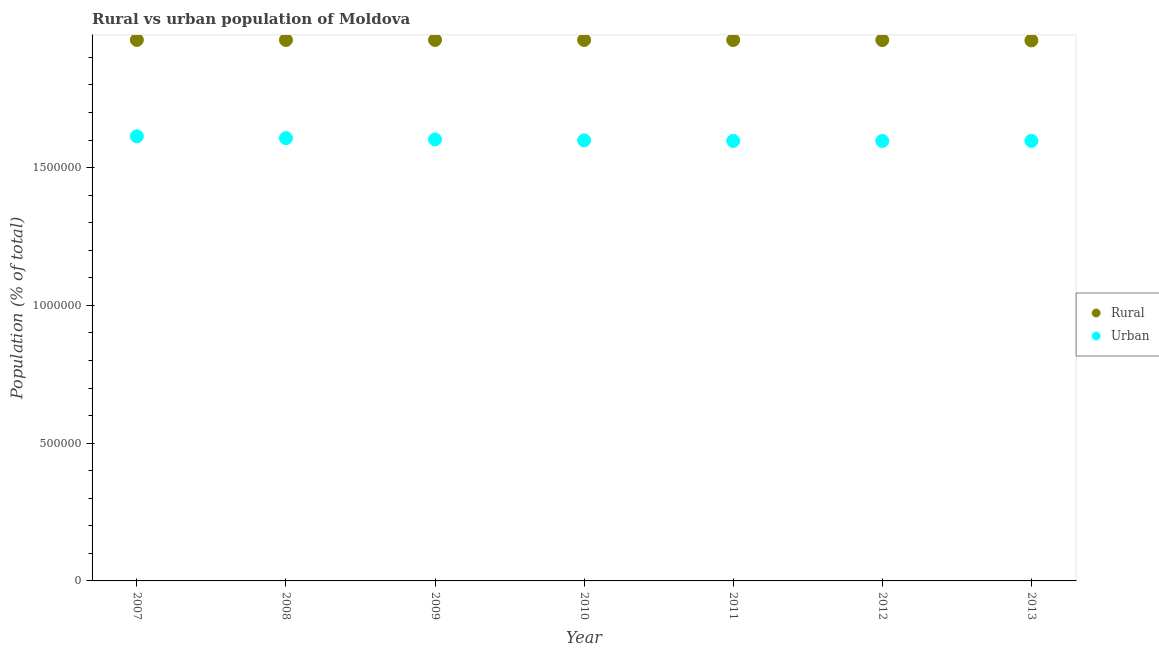What is the urban population density in 2012?
Ensure brevity in your answer.  1.60e+06. Across all years, what is the maximum urban population density?
Your answer should be very brief. 1.61e+06. Across all years, what is the minimum urban population density?
Provide a short and direct response. 1.60e+06. In which year was the rural population density maximum?
Give a very brief answer. 2007. What is the total rural population density in the graph?
Provide a succinct answer. 1.37e+07. What is the difference between the rural population density in 2010 and that in 2013?
Your answer should be compact. 1668. What is the difference between the rural population density in 2007 and the urban population density in 2009?
Offer a very short reply. 3.61e+05. What is the average rural population density per year?
Offer a terse response. 1.96e+06. In the year 2011, what is the difference between the rural population density and urban population density?
Give a very brief answer. 3.66e+05. What is the ratio of the rural population density in 2012 to that in 2013?
Your answer should be compact. 1. Is the difference between the urban population density in 2007 and 2011 greater than the difference between the rural population density in 2007 and 2011?
Offer a terse response. Yes. What is the difference between the highest and the lowest rural population density?
Give a very brief answer. 1849. Is the rural population density strictly greater than the urban population density over the years?
Ensure brevity in your answer.  Yes. How many dotlines are there?
Offer a terse response. 2. How many years are there in the graph?
Provide a short and direct response. 7. What is the difference between two consecutive major ticks on the Y-axis?
Provide a short and direct response. 5.00e+05. Are the values on the major ticks of Y-axis written in scientific E-notation?
Your answer should be compact. No. Where does the legend appear in the graph?
Offer a very short reply. Center right. How many legend labels are there?
Offer a terse response. 2. What is the title of the graph?
Keep it short and to the point. Rural vs urban population of Moldova. What is the label or title of the Y-axis?
Give a very brief answer. Population (% of total). What is the Population (% of total) in Rural in 2007?
Your answer should be very brief. 1.96e+06. What is the Population (% of total) in Urban in 2007?
Ensure brevity in your answer.  1.61e+06. What is the Population (% of total) of Rural in 2008?
Provide a short and direct response. 1.96e+06. What is the Population (% of total) in Urban in 2008?
Keep it short and to the point. 1.61e+06. What is the Population (% of total) in Rural in 2009?
Provide a short and direct response. 1.96e+06. What is the Population (% of total) of Urban in 2009?
Provide a short and direct response. 1.60e+06. What is the Population (% of total) in Rural in 2010?
Your response must be concise. 1.96e+06. What is the Population (% of total) of Urban in 2010?
Offer a very short reply. 1.60e+06. What is the Population (% of total) in Rural in 2011?
Keep it short and to the point. 1.96e+06. What is the Population (% of total) in Urban in 2011?
Make the answer very short. 1.60e+06. What is the Population (% of total) in Rural in 2012?
Provide a succinct answer. 1.96e+06. What is the Population (% of total) in Urban in 2012?
Make the answer very short. 1.60e+06. What is the Population (% of total) of Rural in 2013?
Your response must be concise. 1.96e+06. What is the Population (% of total) of Urban in 2013?
Your answer should be compact. 1.60e+06. Across all years, what is the maximum Population (% of total) in Rural?
Provide a succinct answer. 1.96e+06. Across all years, what is the maximum Population (% of total) of Urban?
Give a very brief answer. 1.61e+06. Across all years, what is the minimum Population (% of total) in Rural?
Offer a terse response. 1.96e+06. Across all years, what is the minimum Population (% of total) in Urban?
Provide a short and direct response. 1.60e+06. What is the total Population (% of total) in Rural in the graph?
Make the answer very short. 1.37e+07. What is the total Population (% of total) in Urban in the graph?
Your response must be concise. 1.12e+07. What is the difference between the Population (% of total) in Rural in 2007 and that in 2008?
Your answer should be very brief. 199. What is the difference between the Population (% of total) of Urban in 2007 and that in 2008?
Ensure brevity in your answer.  6603. What is the difference between the Population (% of total) in Urban in 2007 and that in 2009?
Provide a short and direct response. 1.13e+04. What is the difference between the Population (% of total) in Rural in 2007 and that in 2010?
Make the answer very short. 181. What is the difference between the Population (% of total) of Urban in 2007 and that in 2010?
Give a very brief answer. 1.47e+04. What is the difference between the Population (% of total) of Rural in 2007 and that in 2011?
Ensure brevity in your answer.  354. What is the difference between the Population (% of total) of Urban in 2007 and that in 2011?
Ensure brevity in your answer.  1.66e+04. What is the difference between the Population (% of total) in Rural in 2007 and that in 2012?
Offer a very short reply. 540. What is the difference between the Population (% of total) in Urban in 2007 and that in 2012?
Your answer should be compact. 1.69e+04. What is the difference between the Population (% of total) in Rural in 2007 and that in 2013?
Provide a short and direct response. 1849. What is the difference between the Population (% of total) of Urban in 2007 and that in 2013?
Ensure brevity in your answer.  1.65e+04. What is the difference between the Population (% of total) of Rural in 2008 and that in 2009?
Ensure brevity in your answer.  -197. What is the difference between the Population (% of total) of Urban in 2008 and that in 2009?
Provide a succinct answer. 4701. What is the difference between the Population (% of total) in Rural in 2008 and that in 2010?
Provide a short and direct response. -18. What is the difference between the Population (% of total) in Urban in 2008 and that in 2010?
Your response must be concise. 8081. What is the difference between the Population (% of total) in Rural in 2008 and that in 2011?
Make the answer very short. 155. What is the difference between the Population (% of total) in Urban in 2008 and that in 2011?
Give a very brief answer. 9967. What is the difference between the Population (% of total) in Rural in 2008 and that in 2012?
Ensure brevity in your answer.  341. What is the difference between the Population (% of total) of Urban in 2008 and that in 2012?
Ensure brevity in your answer.  1.02e+04. What is the difference between the Population (% of total) in Rural in 2008 and that in 2013?
Provide a succinct answer. 1650. What is the difference between the Population (% of total) in Urban in 2008 and that in 2013?
Provide a short and direct response. 9892. What is the difference between the Population (% of total) in Rural in 2009 and that in 2010?
Your answer should be compact. 179. What is the difference between the Population (% of total) in Urban in 2009 and that in 2010?
Make the answer very short. 3380. What is the difference between the Population (% of total) in Rural in 2009 and that in 2011?
Offer a very short reply. 352. What is the difference between the Population (% of total) of Urban in 2009 and that in 2011?
Make the answer very short. 5266. What is the difference between the Population (% of total) of Rural in 2009 and that in 2012?
Provide a short and direct response. 538. What is the difference between the Population (% of total) of Urban in 2009 and that in 2012?
Provide a short and direct response. 5547. What is the difference between the Population (% of total) in Rural in 2009 and that in 2013?
Make the answer very short. 1847. What is the difference between the Population (% of total) in Urban in 2009 and that in 2013?
Ensure brevity in your answer.  5191. What is the difference between the Population (% of total) in Rural in 2010 and that in 2011?
Offer a terse response. 173. What is the difference between the Population (% of total) in Urban in 2010 and that in 2011?
Your answer should be very brief. 1886. What is the difference between the Population (% of total) in Rural in 2010 and that in 2012?
Your answer should be compact. 359. What is the difference between the Population (% of total) in Urban in 2010 and that in 2012?
Offer a very short reply. 2167. What is the difference between the Population (% of total) in Rural in 2010 and that in 2013?
Give a very brief answer. 1668. What is the difference between the Population (% of total) in Urban in 2010 and that in 2013?
Provide a short and direct response. 1811. What is the difference between the Population (% of total) in Rural in 2011 and that in 2012?
Keep it short and to the point. 186. What is the difference between the Population (% of total) in Urban in 2011 and that in 2012?
Your response must be concise. 281. What is the difference between the Population (% of total) of Rural in 2011 and that in 2013?
Your answer should be compact. 1495. What is the difference between the Population (% of total) in Urban in 2011 and that in 2013?
Offer a terse response. -75. What is the difference between the Population (% of total) of Rural in 2012 and that in 2013?
Your answer should be very brief. 1309. What is the difference between the Population (% of total) in Urban in 2012 and that in 2013?
Your response must be concise. -356. What is the difference between the Population (% of total) of Rural in 2007 and the Population (% of total) of Urban in 2008?
Offer a very short reply. 3.56e+05. What is the difference between the Population (% of total) in Rural in 2007 and the Population (% of total) in Urban in 2009?
Offer a terse response. 3.61e+05. What is the difference between the Population (% of total) of Rural in 2007 and the Population (% of total) of Urban in 2010?
Provide a short and direct response. 3.65e+05. What is the difference between the Population (% of total) of Rural in 2007 and the Population (% of total) of Urban in 2011?
Ensure brevity in your answer.  3.66e+05. What is the difference between the Population (% of total) in Rural in 2007 and the Population (% of total) in Urban in 2012?
Keep it short and to the point. 3.67e+05. What is the difference between the Population (% of total) in Rural in 2007 and the Population (% of total) in Urban in 2013?
Give a very brief answer. 3.66e+05. What is the difference between the Population (% of total) of Rural in 2008 and the Population (% of total) of Urban in 2009?
Offer a terse response. 3.61e+05. What is the difference between the Population (% of total) of Rural in 2008 and the Population (% of total) of Urban in 2010?
Provide a succinct answer. 3.64e+05. What is the difference between the Population (% of total) of Rural in 2008 and the Population (% of total) of Urban in 2011?
Provide a short and direct response. 3.66e+05. What is the difference between the Population (% of total) in Rural in 2008 and the Population (% of total) in Urban in 2012?
Keep it short and to the point. 3.66e+05. What is the difference between the Population (% of total) in Rural in 2008 and the Population (% of total) in Urban in 2013?
Your response must be concise. 3.66e+05. What is the difference between the Population (% of total) of Rural in 2009 and the Population (% of total) of Urban in 2010?
Provide a short and direct response. 3.65e+05. What is the difference between the Population (% of total) of Rural in 2009 and the Population (% of total) of Urban in 2011?
Keep it short and to the point. 3.66e+05. What is the difference between the Population (% of total) of Rural in 2009 and the Population (% of total) of Urban in 2012?
Ensure brevity in your answer.  3.67e+05. What is the difference between the Population (% of total) of Rural in 2009 and the Population (% of total) of Urban in 2013?
Your response must be concise. 3.66e+05. What is the difference between the Population (% of total) of Rural in 2010 and the Population (% of total) of Urban in 2011?
Keep it short and to the point. 3.66e+05. What is the difference between the Population (% of total) of Rural in 2010 and the Population (% of total) of Urban in 2012?
Your answer should be compact. 3.66e+05. What is the difference between the Population (% of total) of Rural in 2010 and the Population (% of total) of Urban in 2013?
Provide a succinct answer. 3.66e+05. What is the difference between the Population (% of total) in Rural in 2011 and the Population (% of total) in Urban in 2012?
Offer a very short reply. 3.66e+05. What is the difference between the Population (% of total) of Rural in 2011 and the Population (% of total) of Urban in 2013?
Offer a terse response. 3.66e+05. What is the difference between the Population (% of total) of Rural in 2012 and the Population (% of total) of Urban in 2013?
Make the answer very short. 3.66e+05. What is the average Population (% of total) in Rural per year?
Offer a very short reply. 1.96e+06. What is the average Population (% of total) of Urban per year?
Your answer should be very brief. 1.60e+06. In the year 2007, what is the difference between the Population (% of total) of Rural and Population (% of total) of Urban?
Provide a short and direct response. 3.50e+05. In the year 2008, what is the difference between the Population (% of total) in Rural and Population (% of total) in Urban?
Ensure brevity in your answer.  3.56e+05. In the year 2009, what is the difference between the Population (% of total) of Rural and Population (% of total) of Urban?
Your answer should be very brief. 3.61e+05. In the year 2010, what is the difference between the Population (% of total) in Rural and Population (% of total) in Urban?
Your response must be concise. 3.64e+05. In the year 2011, what is the difference between the Population (% of total) of Rural and Population (% of total) of Urban?
Give a very brief answer. 3.66e+05. In the year 2012, what is the difference between the Population (% of total) in Rural and Population (% of total) in Urban?
Your answer should be very brief. 3.66e+05. In the year 2013, what is the difference between the Population (% of total) of Rural and Population (% of total) of Urban?
Your answer should be compact. 3.64e+05. What is the ratio of the Population (% of total) of Urban in 2007 to that in 2008?
Offer a very short reply. 1. What is the ratio of the Population (% of total) of Rural in 2007 to that in 2009?
Offer a very short reply. 1. What is the ratio of the Population (% of total) of Urban in 2007 to that in 2009?
Offer a very short reply. 1.01. What is the ratio of the Population (% of total) of Urban in 2007 to that in 2010?
Ensure brevity in your answer.  1.01. What is the ratio of the Population (% of total) of Urban in 2007 to that in 2011?
Your response must be concise. 1.01. What is the ratio of the Population (% of total) in Urban in 2007 to that in 2012?
Your response must be concise. 1.01. What is the ratio of the Population (% of total) of Urban in 2007 to that in 2013?
Offer a very short reply. 1.01. What is the ratio of the Population (% of total) of Urban in 2008 to that in 2009?
Provide a succinct answer. 1. What is the ratio of the Population (% of total) of Rural in 2008 to that in 2010?
Make the answer very short. 1. What is the ratio of the Population (% of total) of Urban in 2008 to that in 2012?
Ensure brevity in your answer.  1.01. What is the ratio of the Population (% of total) in Urban in 2008 to that in 2013?
Provide a short and direct response. 1.01. What is the ratio of the Population (% of total) of Rural in 2009 to that in 2010?
Provide a succinct answer. 1. What is the ratio of the Population (% of total) of Urban in 2009 to that in 2011?
Make the answer very short. 1. What is the ratio of the Population (% of total) in Rural in 2009 to that in 2012?
Provide a short and direct response. 1. What is the ratio of the Population (% of total) in Urban in 2009 to that in 2012?
Provide a succinct answer. 1. What is the ratio of the Population (% of total) of Rural in 2010 to that in 2011?
Offer a very short reply. 1. What is the ratio of the Population (% of total) of Urban in 2010 to that in 2011?
Offer a terse response. 1. What is the ratio of the Population (% of total) of Rural in 2010 to that in 2012?
Provide a short and direct response. 1. What is the ratio of the Population (% of total) of Urban in 2010 to that in 2012?
Ensure brevity in your answer.  1. What is the ratio of the Population (% of total) of Rural in 2010 to that in 2013?
Provide a succinct answer. 1. What is the ratio of the Population (% of total) in Urban in 2010 to that in 2013?
Keep it short and to the point. 1. What is the ratio of the Population (% of total) of Rural in 2011 to that in 2013?
Your answer should be compact. 1. What is the ratio of the Population (% of total) of Urban in 2011 to that in 2013?
Your answer should be very brief. 1. What is the difference between the highest and the second highest Population (% of total) in Rural?
Provide a succinct answer. 2. What is the difference between the highest and the second highest Population (% of total) of Urban?
Provide a short and direct response. 6603. What is the difference between the highest and the lowest Population (% of total) in Rural?
Ensure brevity in your answer.  1849. What is the difference between the highest and the lowest Population (% of total) in Urban?
Make the answer very short. 1.69e+04. 